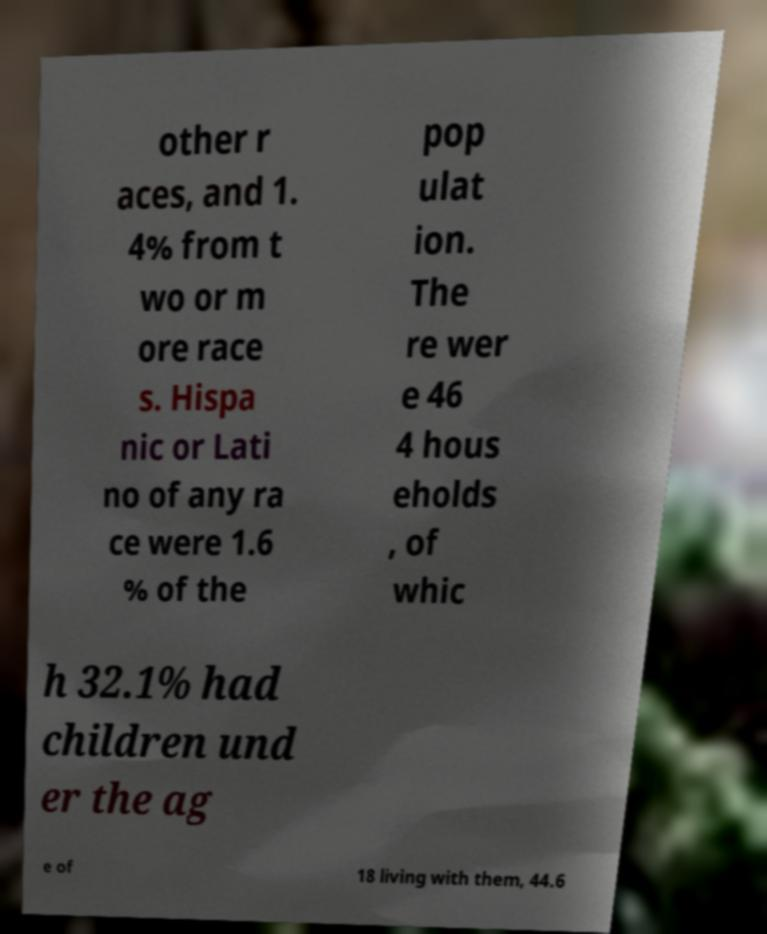For documentation purposes, I need the text within this image transcribed. Could you provide that? other r aces, and 1. 4% from t wo or m ore race s. Hispa nic or Lati no of any ra ce were 1.6 % of the pop ulat ion. The re wer e 46 4 hous eholds , of whic h 32.1% had children und er the ag e of 18 living with them, 44.6 